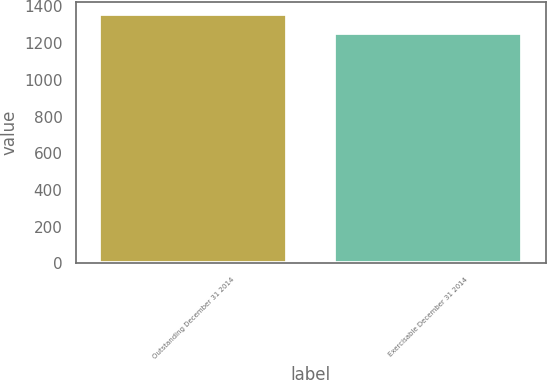<chart> <loc_0><loc_0><loc_500><loc_500><bar_chart><fcel>Outstanding December 31 2014<fcel>Exercisable December 31 2014<nl><fcel>1358<fcel>1257<nl></chart> 